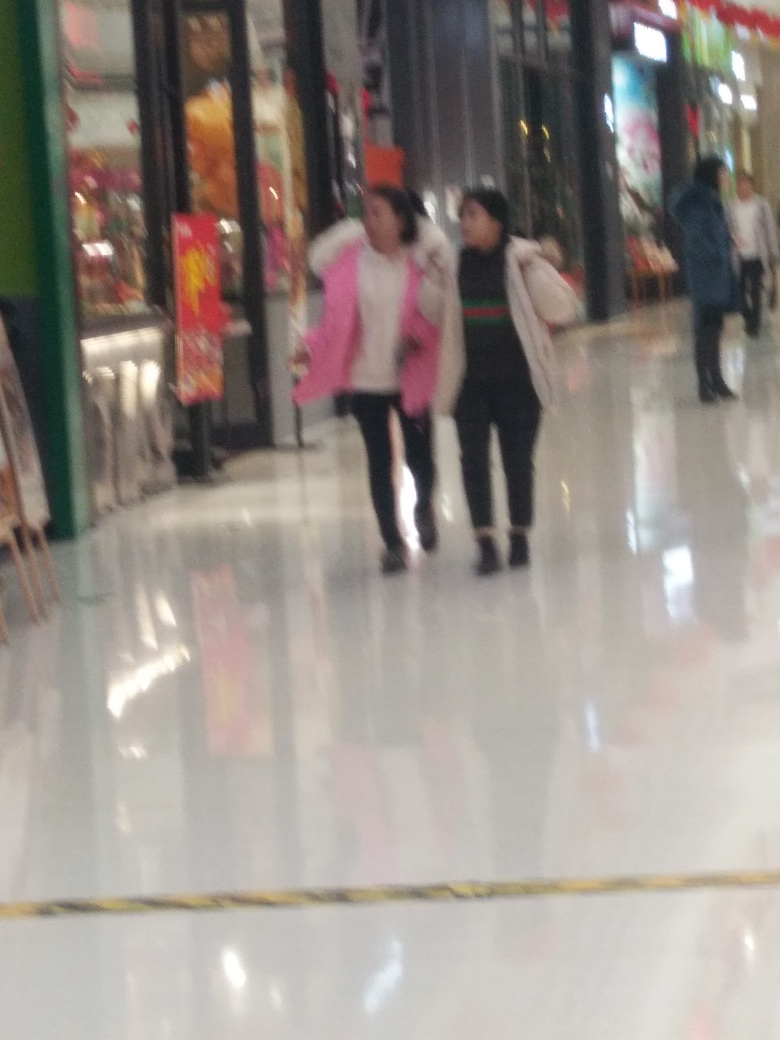Can you describe the fashion style of the individuals in this image? Certainly! The individuals in the image are wearing casual attire. One appears to have a pink, hooded garment that seems suitable for cooler weather, while the other is wearing a black and white outfit with a dark jacket or coat. Both individuals carry bags, indicating they might have been shopping. 